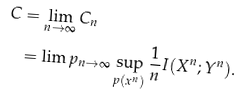Convert formula to latex. <formula><loc_0><loc_0><loc_500><loc_500>C & = \lim _ { n \to \infty } C _ { n } \\ & = \lim p _ { n \to \infty } \sup _ { p ( x ^ { n } ) } \frac { 1 } { n } I ( X ^ { n } ; Y ^ { n } ) .</formula> 